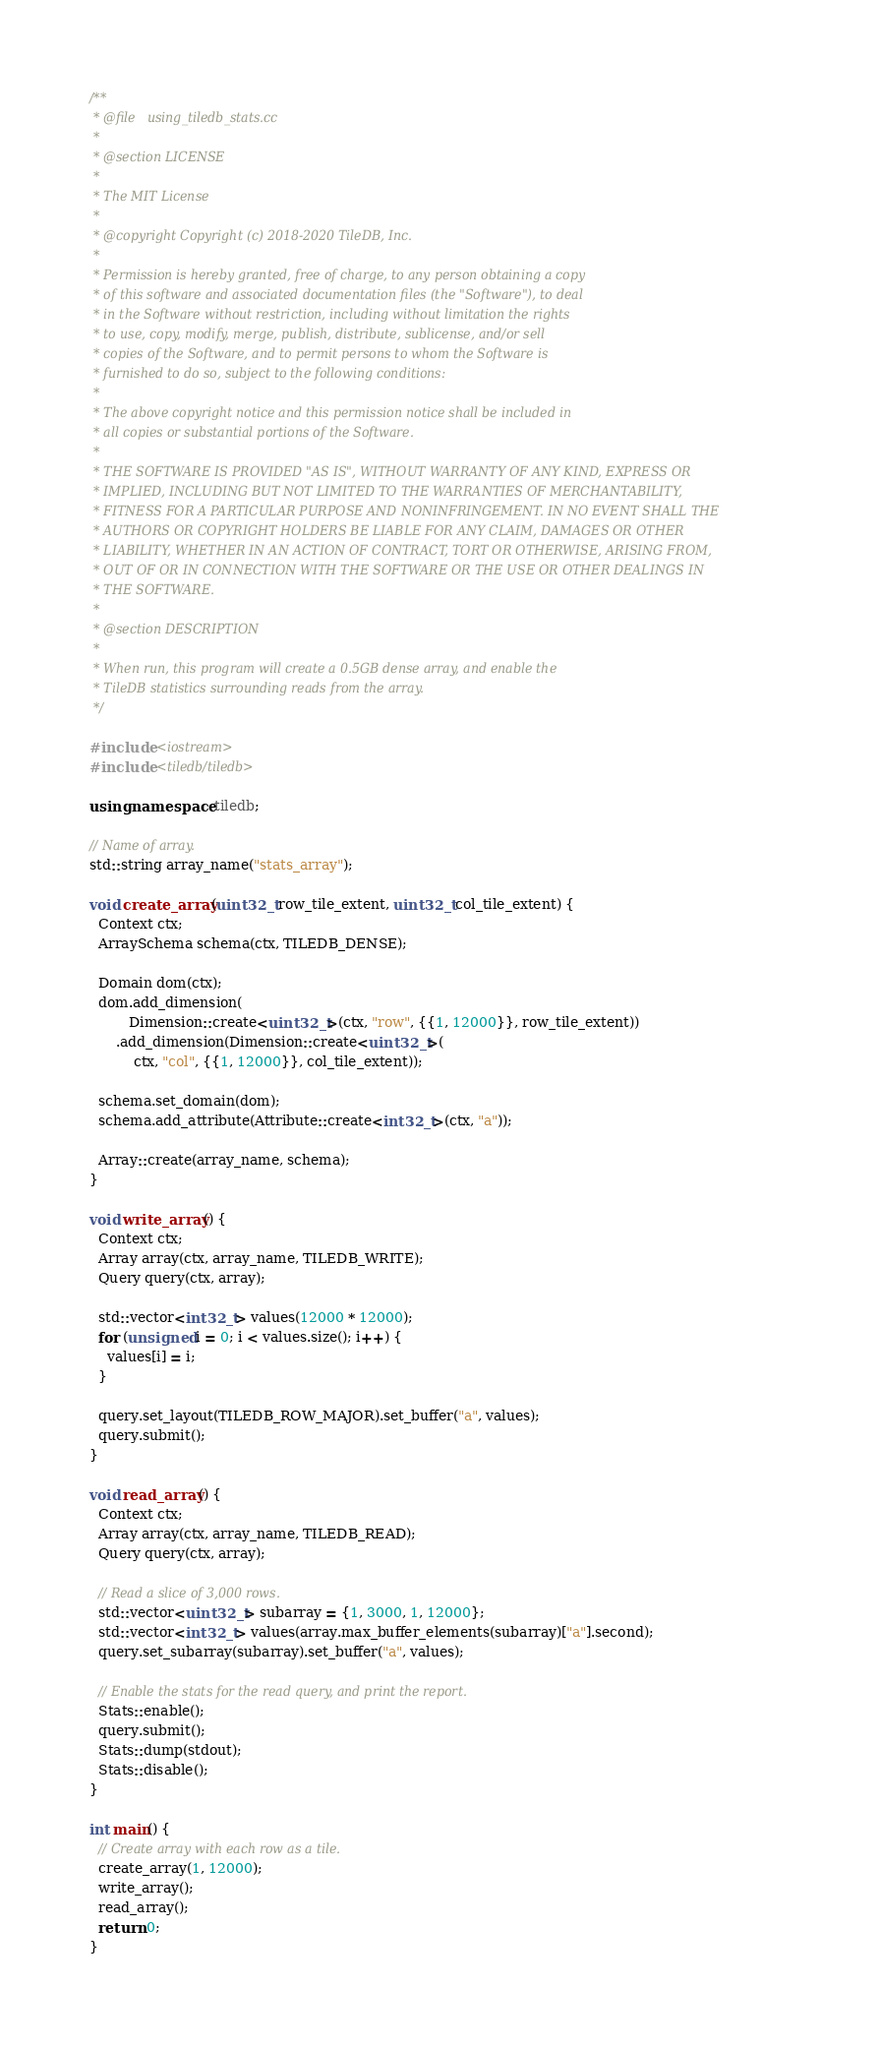Convert code to text. <code><loc_0><loc_0><loc_500><loc_500><_C++_>/**
 * @file   using_tiledb_stats.cc
 *
 * @section LICENSE
 *
 * The MIT License
 *
 * @copyright Copyright (c) 2018-2020 TileDB, Inc.
 *
 * Permission is hereby granted, free of charge, to any person obtaining a copy
 * of this software and associated documentation files (the "Software"), to deal
 * in the Software without restriction, including without limitation the rights
 * to use, copy, modify, merge, publish, distribute, sublicense, and/or sell
 * copies of the Software, and to permit persons to whom the Software is
 * furnished to do so, subject to the following conditions:
 *
 * The above copyright notice and this permission notice shall be included in
 * all copies or substantial portions of the Software.
 *
 * THE SOFTWARE IS PROVIDED "AS IS", WITHOUT WARRANTY OF ANY KIND, EXPRESS OR
 * IMPLIED, INCLUDING BUT NOT LIMITED TO THE WARRANTIES OF MERCHANTABILITY,
 * FITNESS FOR A PARTICULAR PURPOSE AND NONINFRINGEMENT. IN NO EVENT SHALL THE
 * AUTHORS OR COPYRIGHT HOLDERS BE LIABLE FOR ANY CLAIM, DAMAGES OR OTHER
 * LIABILITY, WHETHER IN AN ACTION OF CONTRACT, TORT OR OTHERWISE, ARISING FROM,
 * OUT OF OR IN CONNECTION WITH THE SOFTWARE OR THE USE OR OTHER DEALINGS IN
 * THE SOFTWARE.
 *
 * @section DESCRIPTION
 *
 * When run, this program will create a 0.5GB dense array, and enable the
 * TileDB statistics surrounding reads from the array.
 */

#include <iostream>
#include <tiledb/tiledb>

using namespace tiledb;

// Name of array.
std::string array_name("stats_array");

void create_array(uint32_t row_tile_extent, uint32_t col_tile_extent) {
  Context ctx;
  ArraySchema schema(ctx, TILEDB_DENSE);

  Domain dom(ctx);
  dom.add_dimension(
         Dimension::create<uint32_t>(ctx, "row", {{1, 12000}}, row_tile_extent))
      .add_dimension(Dimension::create<uint32_t>(
          ctx, "col", {{1, 12000}}, col_tile_extent));

  schema.set_domain(dom);
  schema.add_attribute(Attribute::create<int32_t>(ctx, "a"));

  Array::create(array_name, schema);
}

void write_array() {
  Context ctx;
  Array array(ctx, array_name, TILEDB_WRITE);
  Query query(ctx, array);

  std::vector<int32_t> values(12000 * 12000);
  for (unsigned i = 0; i < values.size(); i++) {
    values[i] = i;
  }

  query.set_layout(TILEDB_ROW_MAJOR).set_buffer("a", values);
  query.submit();
}

void read_array() {
  Context ctx;
  Array array(ctx, array_name, TILEDB_READ);
  Query query(ctx, array);

  // Read a slice of 3,000 rows.
  std::vector<uint32_t> subarray = {1, 3000, 1, 12000};
  std::vector<int32_t> values(array.max_buffer_elements(subarray)["a"].second);
  query.set_subarray(subarray).set_buffer("a", values);

  // Enable the stats for the read query, and print the report.
  Stats::enable();
  query.submit();
  Stats::dump(stdout);
  Stats::disable();
}

int main() {
  // Create array with each row as a tile.
  create_array(1, 12000);
  write_array();
  read_array();
  return 0;
}
</code> 